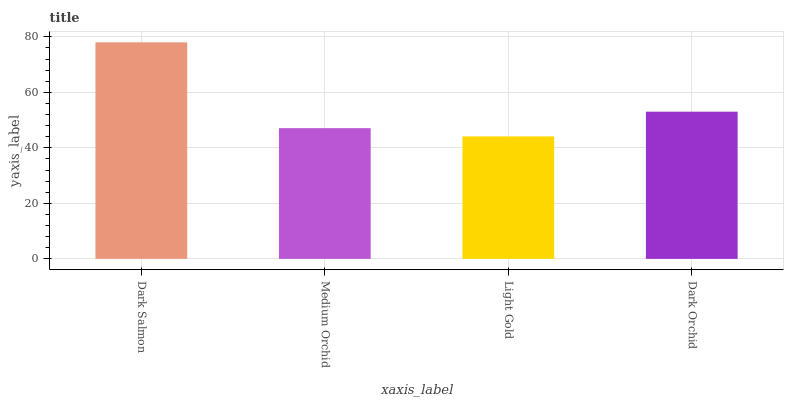Is Light Gold the minimum?
Answer yes or no. Yes. Is Dark Salmon the maximum?
Answer yes or no. Yes. Is Medium Orchid the minimum?
Answer yes or no. No. Is Medium Orchid the maximum?
Answer yes or no. No. Is Dark Salmon greater than Medium Orchid?
Answer yes or no. Yes. Is Medium Orchid less than Dark Salmon?
Answer yes or no. Yes. Is Medium Orchid greater than Dark Salmon?
Answer yes or no. No. Is Dark Salmon less than Medium Orchid?
Answer yes or no. No. Is Dark Orchid the high median?
Answer yes or no. Yes. Is Medium Orchid the low median?
Answer yes or no. Yes. Is Light Gold the high median?
Answer yes or no. No. Is Dark Orchid the low median?
Answer yes or no. No. 